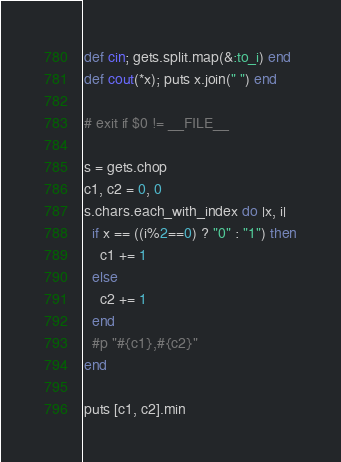Convert code to text. <code><loc_0><loc_0><loc_500><loc_500><_Ruby_>def cin; gets.split.map(&:to_i) end
def cout(*x); puts x.join(" ") end

# exit if $0 != __FILE__

s = gets.chop
c1, c2 = 0, 0
s.chars.each_with_index do |x, i|
  if x == ((i%2==0) ? "0" : "1") then
    c1 += 1
  else
    c2 += 1
  end
  #p "#{c1},#{c2}"
end

puts [c1, c2].min
</code> 